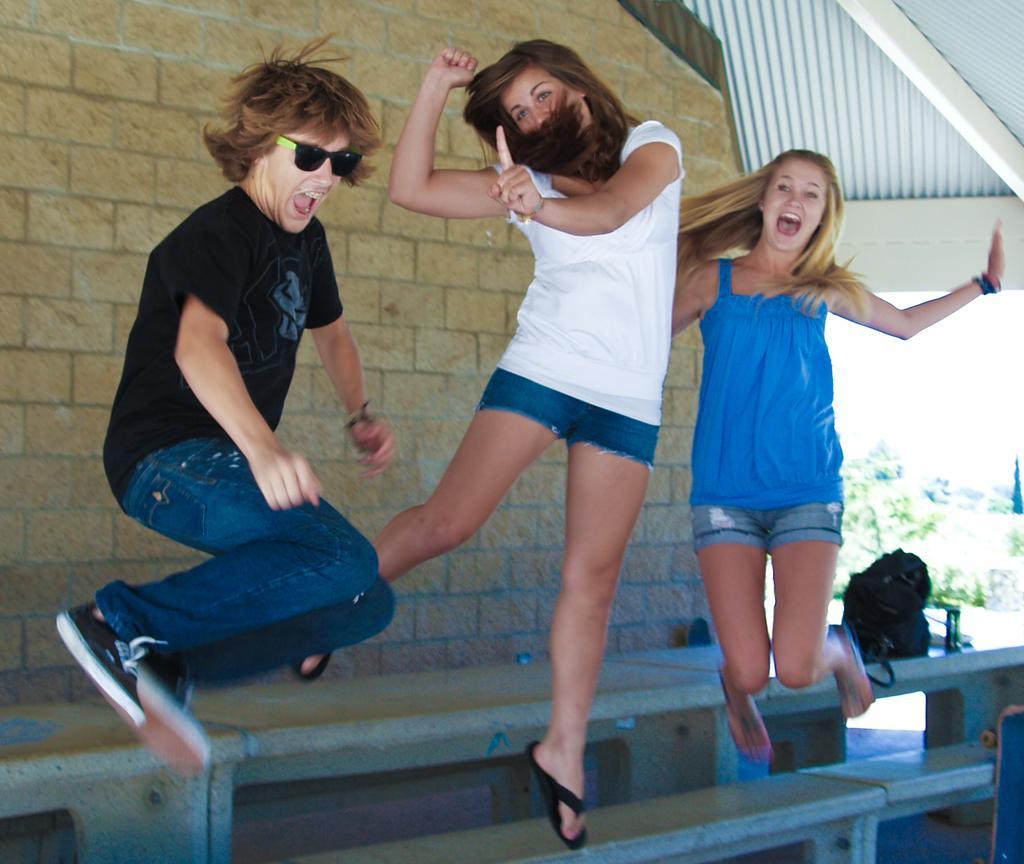Describe this image in one or two sentences. In this image there are three persons jumping. Below them there are benches and table. On the table there is a bag. Behind them there is a wall of the house. To the right there are plants. 